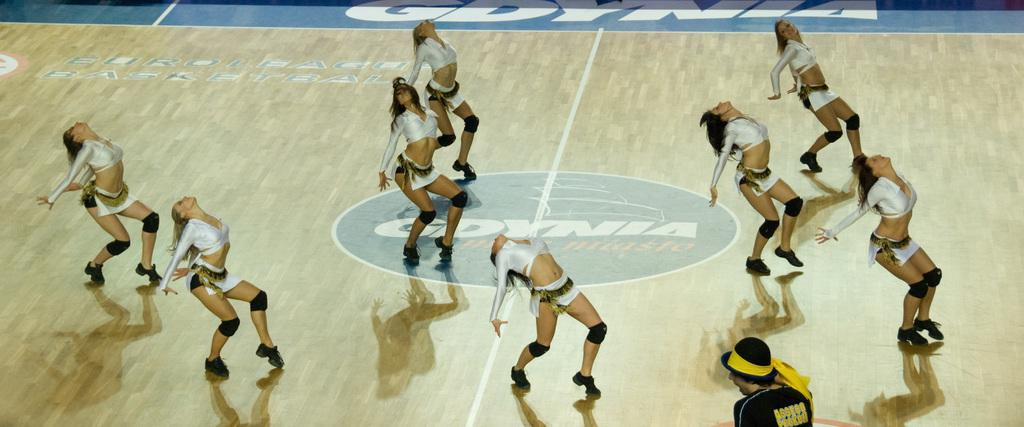What type of performers are in the image? There are cheer girls in the image. What are the cheer girls wearing? The cheer girls are wearing white dresses. What are the cheer girls doing in the image? The cheer girls are dancing. What is the material of the floor they are dancing on? The floor they are dancing on is wooden. What is the sun doing in the image? There is no sun present in the image; it is an indoor scene with cheer girls dancing on a wooden floor. 